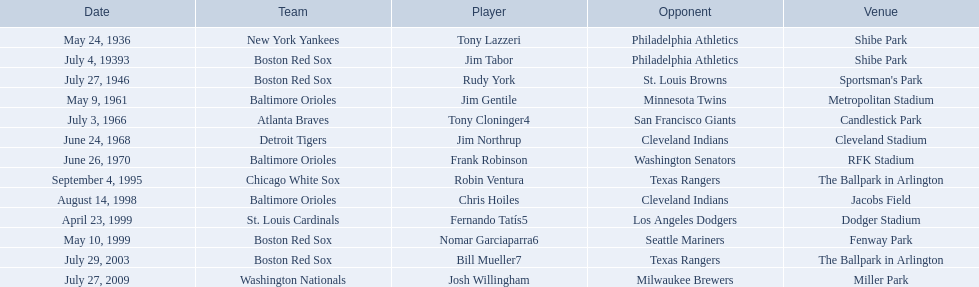What are the dates? May 24, 1936, July 4, 19393, July 27, 1946, May 9, 1961, July 3, 1966, June 24, 1968, June 26, 1970, September 4, 1995, August 14, 1998, April 23, 1999, May 10, 1999, July 29, 2003, July 27, 2009. Which date is in 1936? May 24, 1936. What player is listed for this date? Tony Lazzeri. 